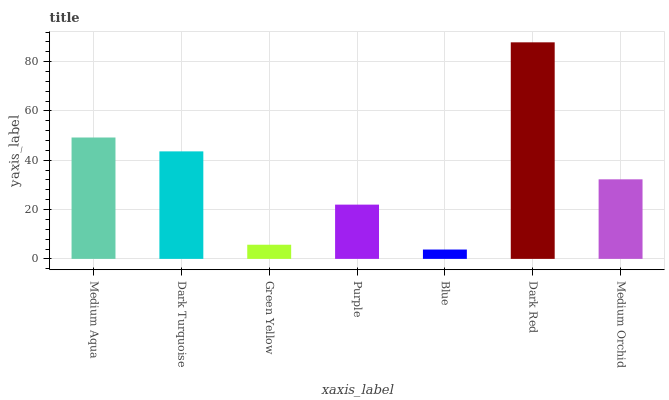Is Blue the minimum?
Answer yes or no. Yes. Is Dark Red the maximum?
Answer yes or no. Yes. Is Dark Turquoise the minimum?
Answer yes or no. No. Is Dark Turquoise the maximum?
Answer yes or no. No. Is Medium Aqua greater than Dark Turquoise?
Answer yes or no. Yes. Is Dark Turquoise less than Medium Aqua?
Answer yes or no. Yes. Is Dark Turquoise greater than Medium Aqua?
Answer yes or no. No. Is Medium Aqua less than Dark Turquoise?
Answer yes or no. No. Is Medium Orchid the high median?
Answer yes or no. Yes. Is Medium Orchid the low median?
Answer yes or no. Yes. Is Dark Red the high median?
Answer yes or no. No. Is Dark Red the low median?
Answer yes or no. No. 